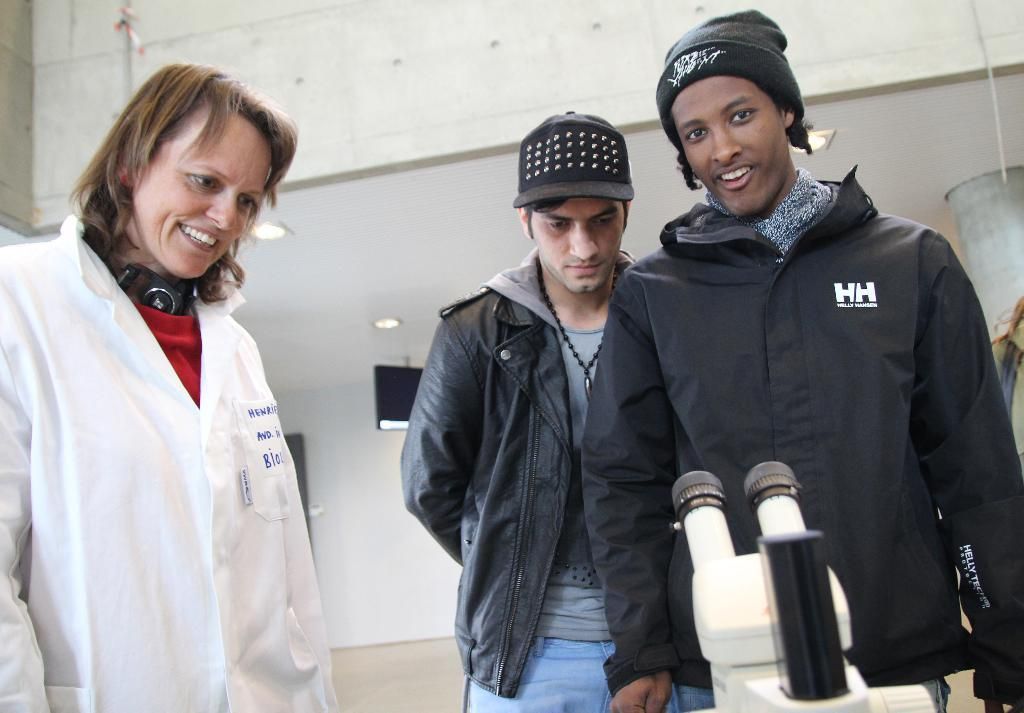How many people are in the group in the image? There is a group of people in the image, but the exact number is not specified. What are some people in the group wearing? Some people in the group are wearing caps. What object is in front of the group? There is a microscope in front of the group. What can be seen in the background of the image? There are lights and a screen visible in the background of the image. What type of flower is being used as a centerpiece for the dinner table in the image? There is no dinner table or flower present in the image. Is there a crook visible in the image? There is no crook present in the image. 